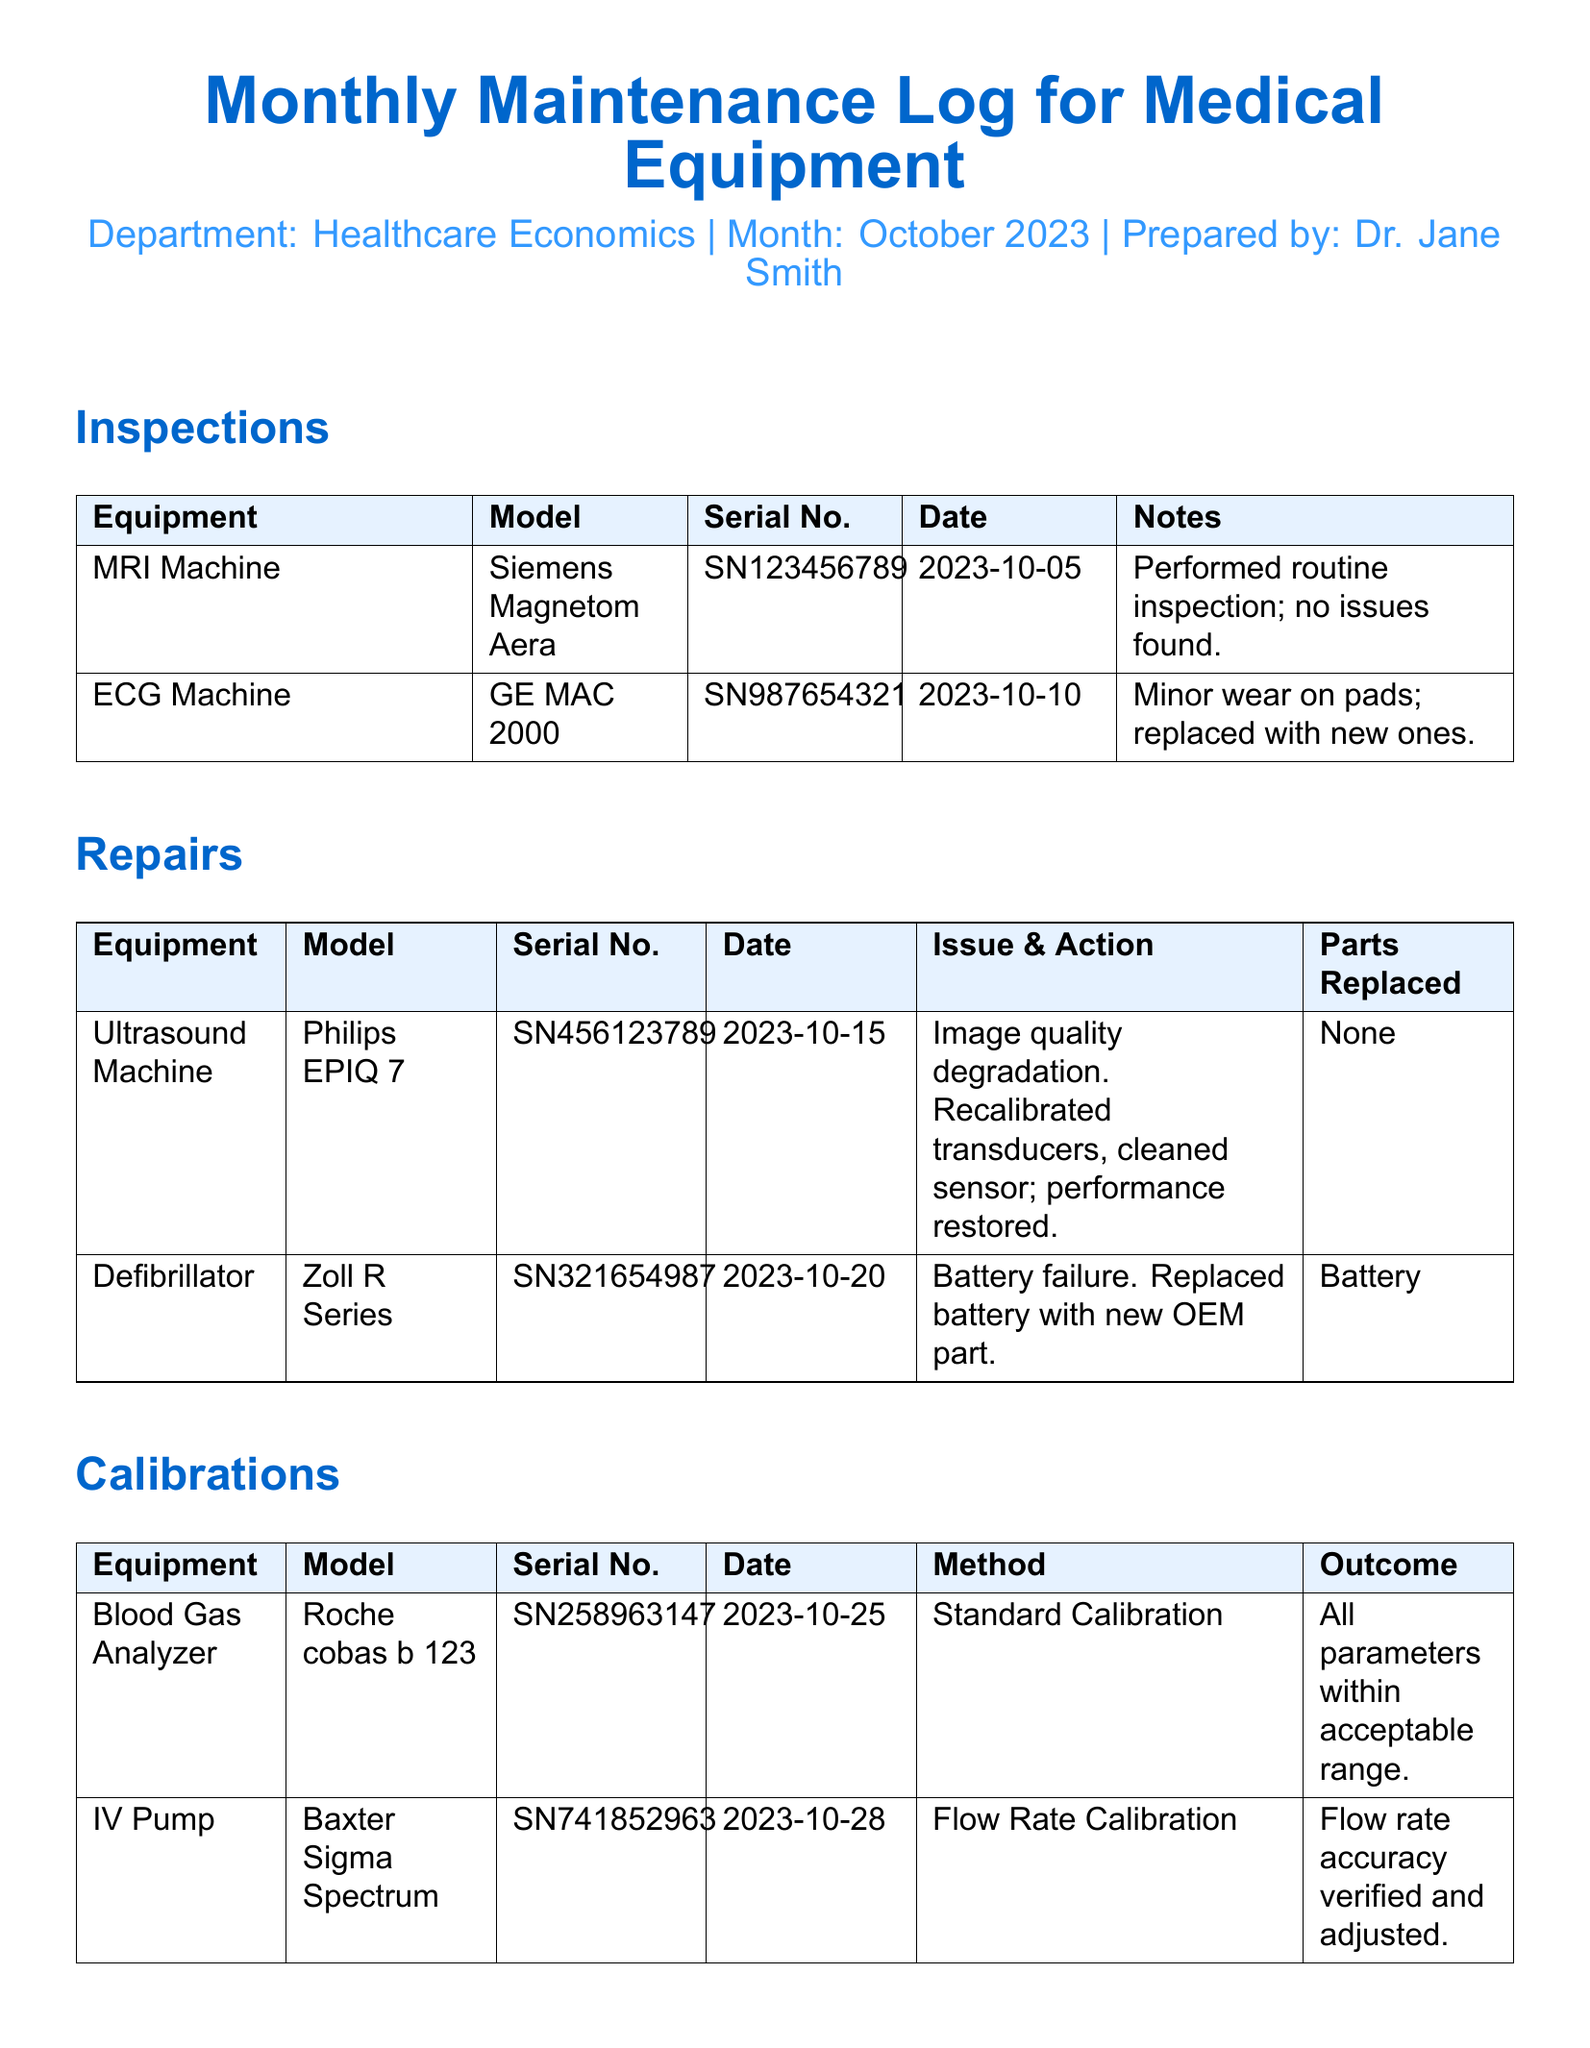What is the date of the routine inspection for the MRI Machine? The date listed in the inspections section for the MRI Machine is 2023-10-05.
Answer: 2023-10-05 What issue was reported for the Defibrillator? The issue listed for the Defibrillator in the repairs section is battery failure.
Answer: Battery failure What model is the Blood Gas Analyzer? The model mentioned for the Blood Gas Analyzer in the calibrations section is Roche cobas b 123.
Answer: Roche cobas b 123 How many parts were replaced for the Ultrasound Machine? No parts were mentioned as replaced for the Ultrasound Machine in the repairs section.
Answer: None What was the outcome of the calibration for the IV Pump? The outcome mentioned for the IV Pump calibration was flow rate accuracy verified and adjusted.
Answer: Flow rate accuracy verified and adjusted What type of maintenance was performed on the ECG Machine? The maintenance performed on the ECG Machine was a routine inspection and replacement of minor parts.
Answer: Routine inspection and replacement of minor parts Which equipment had an issue with image quality? The equipment that had an issue with image quality is the Ultrasound Machine.
Answer: Ultrasound Machine What date was the calibration of the Blood Gas Analyzer performed? The date for the calibration of the Blood Gas Analyzer listed in the document is 2023-10-25.
Answer: 2023-10-25 What was the action taken for the ECG Machine's minor wear? The action taken was to replace the pads with new ones.
Answer: Replace the pads with new ones 